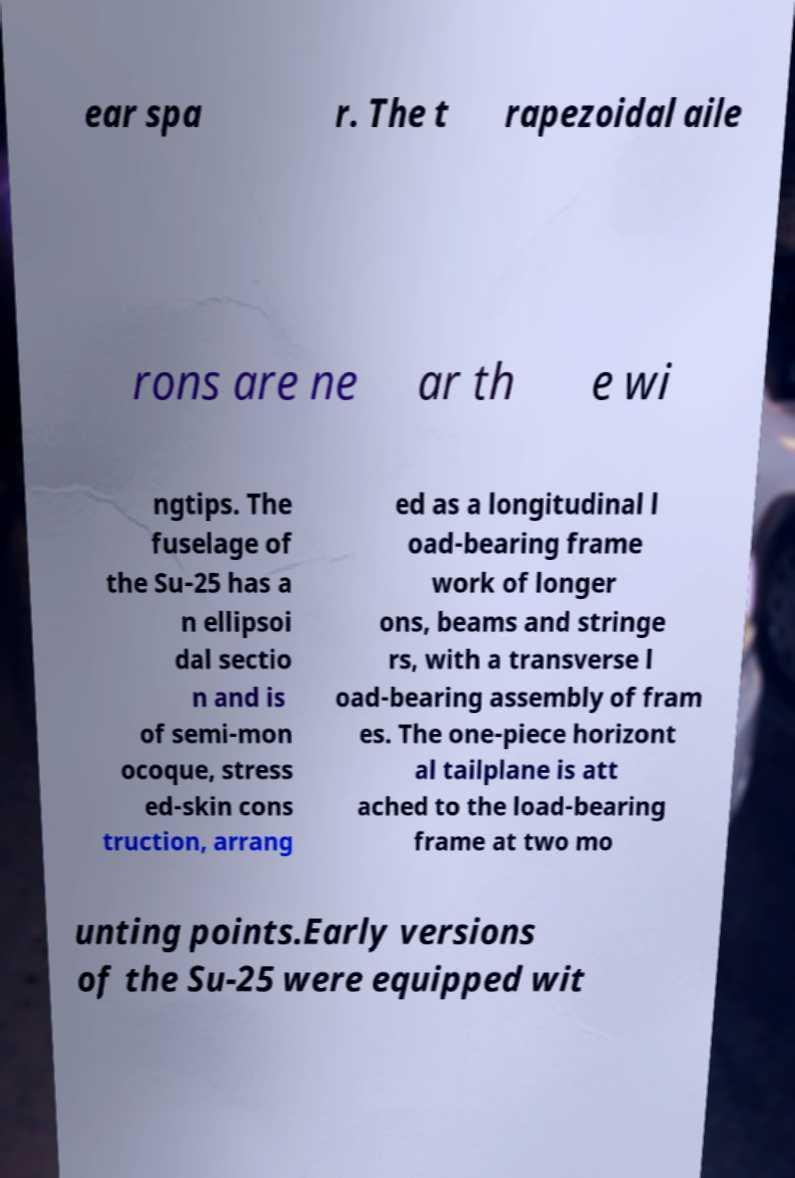Could you assist in decoding the text presented in this image and type it out clearly? ear spa r. The t rapezoidal aile rons are ne ar th e wi ngtips. The fuselage of the Su-25 has a n ellipsoi dal sectio n and is of semi-mon ocoque, stress ed-skin cons truction, arrang ed as a longitudinal l oad-bearing frame work of longer ons, beams and stringe rs, with a transverse l oad-bearing assembly of fram es. The one-piece horizont al tailplane is att ached to the load-bearing frame at two mo unting points.Early versions of the Su-25 were equipped wit 